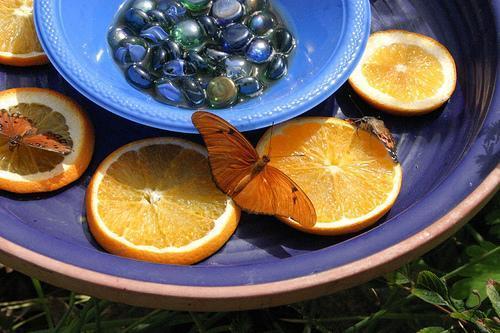How many butterflies are in this scene?
Give a very brief answer. 3. How many oranges are visible?
Give a very brief answer. 5. 